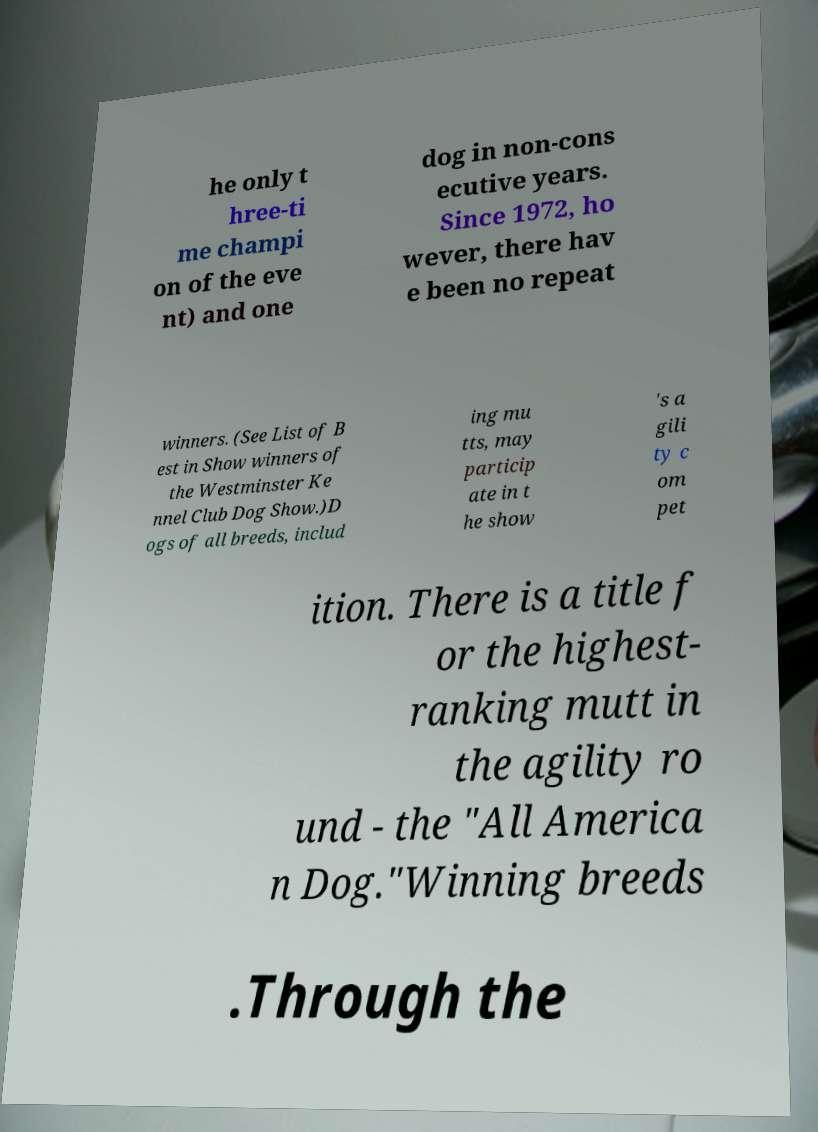Can you read and provide the text displayed in the image?This photo seems to have some interesting text. Can you extract and type it out for me? he only t hree-ti me champi on of the eve nt) and one dog in non-cons ecutive years. Since 1972, ho wever, there hav e been no repeat winners. (See List of B est in Show winners of the Westminster Ke nnel Club Dog Show.)D ogs of all breeds, includ ing mu tts, may particip ate in t he show 's a gili ty c om pet ition. There is a title f or the highest- ranking mutt in the agility ro und - the "All America n Dog."Winning breeds .Through the 